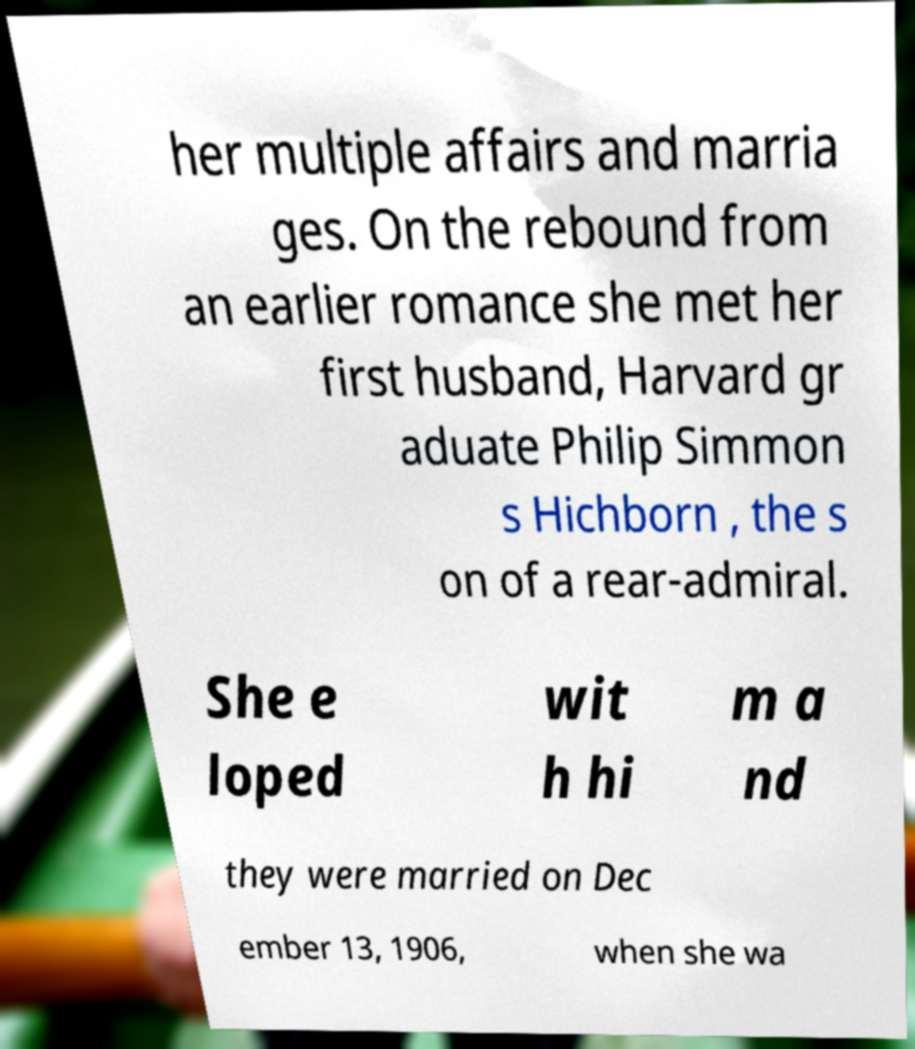Please identify and transcribe the text found in this image. her multiple affairs and marria ges. On the rebound from an earlier romance she met her first husband, Harvard gr aduate Philip Simmon s Hichborn , the s on of a rear-admiral. She e loped wit h hi m a nd they were married on Dec ember 13, 1906, when she wa 